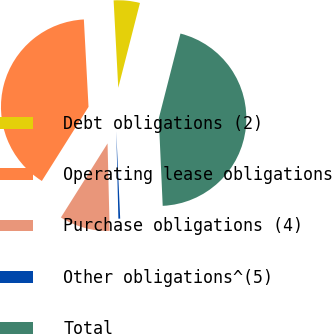Convert chart to OTSL. <chart><loc_0><loc_0><loc_500><loc_500><pie_chart><fcel>Debt obligations (2)<fcel>Operating lease obligations<fcel>Purchase obligations (4)<fcel>Other obligations^(5)<fcel>Total<nl><fcel>4.83%<fcel>40.21%<fcel>9.33%<fcel>0.33%<fcel>45.31%<nl></chart> 